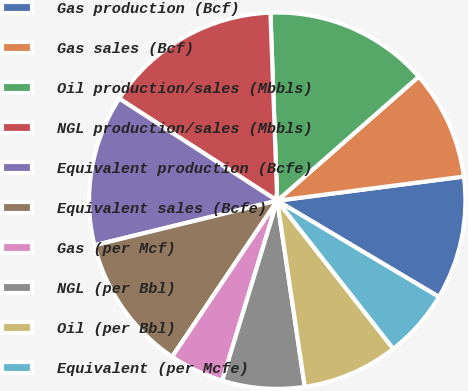Convert chart. <chart><loc_0><loc_0><loc_500><loc_500><pie_chart><fcel>Gas production (Bcf)<fcel>Gas sales (Bcf)<fcel>Oil production/sales (Mbbls)<fcel>NGL production/sales (Mbbls)<fcel>Equivalent production (Bcfe)<fcel>Equivalent sales (Bcfe)<fcel>Gas (per Mcf)<fcel>NGL (per Bbl)<fcel>Oil (per Bbl)<fcel>Equivalent (per Mcfe)<nl><fcel>10.59%<fcel>9.41%<fcel>14.12%<fcel>15.29%<fcel>12.94%<fcel>11.76%<fcel>4.71%<fcel>7.06%<fcel>8.24%<fcel>5.88%<nl></chart> 